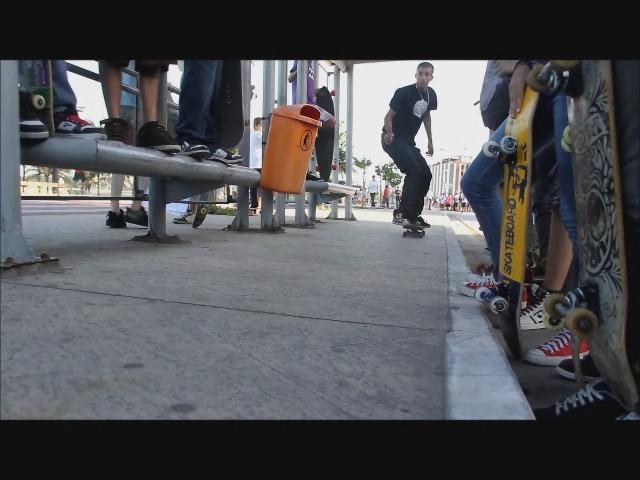What is the orange object used for?

Choices:
A) storage
B) scoring
C) trash
D) blocking trash 